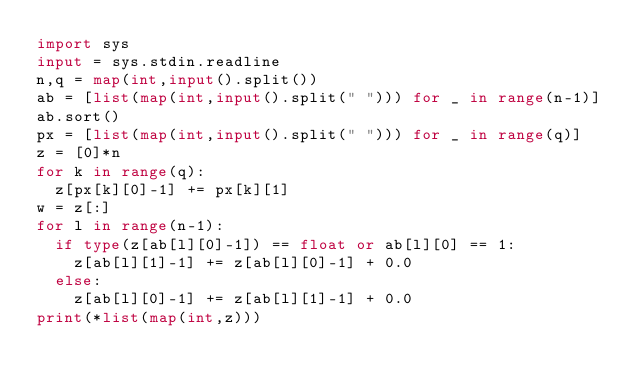<code> <loc_0><loc_0><loc_500><loc_500><_Python_>import sys
input = sys.stdin.readline
n,q = map(int,input().split())
ab = [list(map(int,input().split(" "))) for _ in range(n-1)]
ab.sort()
px = [list(map(int,input().split(" "))) for _ in range(q)]
z = [0]*n
for k in range(q):
  z[px[k][0]-1] += px[k][1]
w = z[:]
for l in range(n-1):
  if type(z[ab[l][0]-1]) == float or ab[l][0] == 1:
    z[ab[l][1]-1] += z[ab[l][0]-1] + 0.0
  else:
    z[ab[l][0]-1] += z[ab[l][1]-1] + 0.0
print(*list(map(int,z)))</code> 